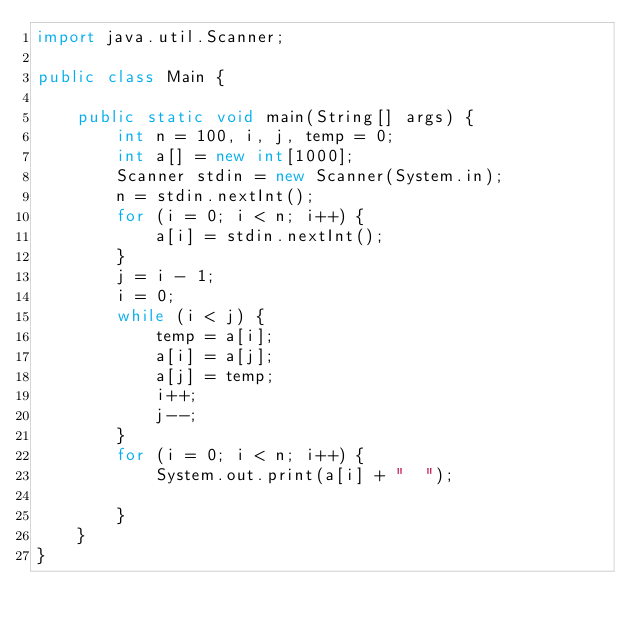Convert code to text. <code><loc_0><loc_0><loc_500><loc_500><_Java_>import java.util.Scanner;

public class Main {

	public static void main(String[] args) {
		int n = 100, i, j, temp = 0;
		int a[] = new int[1000];
		Scanner stdin = new Scanner(System.in);
		n = stdin.nextInt();
		for (i = 0; i < n; i++) {
			a[i] = stdin.nextInt();
		}
		j = i - 1;
		i = 0;
		while (i < j) {
			temp = a[i];
			a[i] = a[j];
			a[j] = temp;
			i++;
			j--;
		}
		for (i = 0; i < n; i++) {
			System.out.print(a[i] + "  ");

		}
	}
}</code> 